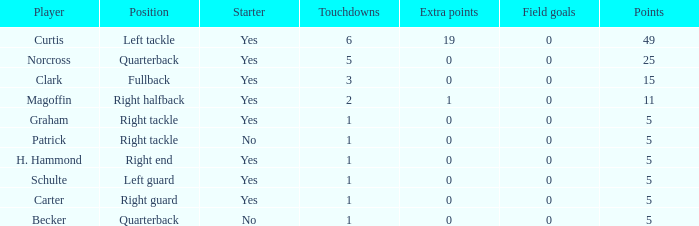What is the quantity of field goals corresponding to 19 extra points? 1.0. 